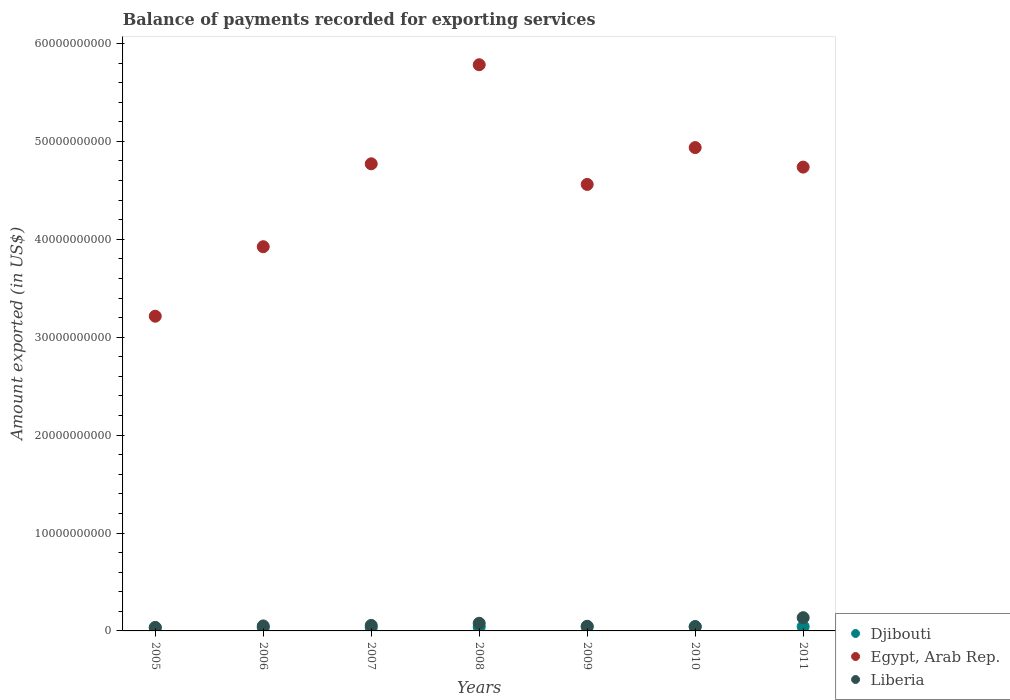How many different coloured dotlines are there?
Offer a very short reply. 3. Is the number of dotlines equal to the number of legend labels?
Provide a succinct answer. Yes. What is the amount exported in Liberia in 2008?
Your answer should be compact. 7.81e+08. Across all years, what is the maximum amount exported in Djibouti?
Provide a short and direct response. 4.40e+08. Across all years, what is the minimum amount exported in Liberia?
Offer a terse response. 3.55e+08. What is the total amount exported in Egypt, Arab Rep. in the graph?
Offer a very short reply. 3.19e+11. What is the difference between the amount exported in Liberia in 2006 and that in 2010?
Provide a succinct answer. 7.90e+07. What is the difference between the amount exported in Liberia in 2008 and the amount exported in Egypt, Arab Rep. in 2010?
Give a very brief answer. -4.86e+1. What is the average amount exported in Egypt, Arab Rep. per year?
Make the answer very short. 4.56e+1. In the year 2010, what is the difference between the amount exported in Liberia and amount exported in Djibouti?
Give a very brief answer. -8.59e+06. What is the ratio of the amount exported in Djibouti in 2005 to that in 2011?
Offer a terse response. 0.73. Is the amount exported in Liberia in 2008 less than that in 2009?
Ensure brevity in your answer.  No. What is the difference between the highest and the second highest amount exported in Egypt, Arab Rep.?
Make the answer very short. 8.46e+09. What is the difference between the highest and the lowest amount exported in Liberia?
Your answer should be very brief. 9.97e+08. Is the sum of the amount exported in Liberia in 2008 and 2009 greater than the maximum amount exported in Djibouti across all years?
Your response must be concise. Yes. Is the amount exported in Egypt, Arab Rep. strictly greater than the amount exported in Liberia over the years?
Make the answer very short. Yes. Is the amount exported in Djibouti strictly less than the amount exported in Egypt, Arab Rep. over the years?
Your response must be concise. Yes. How many dotlines are there?
Give a very brief answer. 3. How many years are there in the graph?
Offer a terse response. 7. What is the difference between two consecutive major ticks on the Y-axis?
Your answer should be very brief. 1.00e+1. Does the graph contain any zero values?
Your response must be concise. No. What is the title of the graph?
Provide a succinct answer. Balance of payments recorded for exporting services. Does "Ethiopia" appear as one of the legend labels in the graph?
Make the answer very short. No. What is the label or title of the Y-axis?
Your answer should be compact. Amount exported (in US$). What is the Amount exported (in US$) of Djibouti in 2005?
Your answer should be very brief. 3.20e+08. What is the Amount exported (in US$) in Egypt, Arab Rep. in 2005?
Ensure brevity in your answer.  3.21e+1. What is the Amount exported (in US$) in Liberia in 2005?
Make the answer very short. 3.55e+08. What is the Amount exported (in US$) of Djibouti in 2006?
Keep it short and to the point. 3.41e+08. What is the Amount exported (in US$) in Egypt, Arab Rep. in 2006?
Your answer should be compact. 3.92e+1. What is the Amount exported (in US$) of Liberia in 2006?
Your response must be concise. 5.09e+08. What is the Amount exported (in US$) in Djibouti in 2007?
Provide a succinct answer. 3.29e+08. What is the Amount exported (in US$) in Egypt, Arab Rep. in 2007?
Give a very brief answer. 4.77e+1. What is the Amount exported (in US$) of Liberia in 2007?
Ensure brevity in your answer.  5.62e+08. What is the Amount exported (in US$) of Djibouti in 2008?
Offer a terse response. 3.98e+08. What is the Amount exported (in US$) of Egypt, Arab Rep. in 2008?
Ensure brevity in your answer.  5.78e+1. What is the Amount exported (in US$) in Liberia in 2008?
Your answer should be very brief. 7.81e+08. What is the Amount exported (in US$) in Djibouti in 2009?
Provide a short and direct response. 4.23e+08. What is the Amount exported (in US$) in Egypt, Arab Rep. in 2009?
Make the answer very short. 4.56e+1. What is the Amount exported (in US$) in Liberia in 2009?
Your answer should be very brief. 4.72e+08. What is the Amount exported (in US$) of Djibouti in 2010?
Provide a succinct answer. 4.39e+08. What is the Amount exported (in US$) in Egypt, Arab Rep. in 2010?
Offer a terse response. 4.94e+1. What is the Amount exported (in US$) of Liberia in 2010?
Offer a very short reply. 4.30e+08. What is the Amount exported (in US$) in Djibouti in 2011?
Make the answer very short. 4.40e+08. What is the Amount exported (in US$) of Egypt, Arab Rep. in 2011?
Ensure brevity in your answer.  4.74e+1. What is the Amount exported (in US$) in Liberia in 2011?
Offer a very short reply. 1.35e+09. Across all years, what is the maximum Amount exported (in US$) of Djibouti?
Give a very brief answer. 4.40e+08. Across all years, what is the maximum Amount exported (in US$) of Egypt, Arab Rep.?
Give a very brief answer. 5.78e+1. Across all years, what is the maximum Amount exported (in US$) of Liberia?
Provide a short and direct response. 1.35e+09. Across all years, what is the minimum Amount exported (in US$) of Djibouti?
Your answer should be very brief. 3.20e+08. Across all years, what is the minimum Amount exported (in US$) of Egypt, Arab Rep.?
Offer a terse response. 3.21e+1. Across all years, what is the minimum Amount exported (in US$) of Liberia?
Provide a succinct answer. 3.55e+08. What is the total Amount exported (in US$) of Djibouti in the graph?
Your answer should be compact. 2.69e+09. What is the total Amount exported (in US$) in Egypt, Arab Rep. in the graph?
Your answer should be compact. 3.19e+11. What is the total Amount exported (in US$) of Liberia in the graph?
Provide a short and direct response. 4.46e+09. What is the difference between the Amount exported (in US$) of Djibouti in 2005 and that in 2006?
Offer a very short reply. -2.17e+07. What is the difference between the Amount exported (in US$) of Egypt, Arab Rep. in 2005 and that in 2006?
Your response must be concise. -7.10e+09. What is the difference between the Amount exported (in US$) in Liberia in 2005 and that in 2006?
Your answer should be very brief. -1.55e+08. What is the difference between the Amount exported (in US$) in Djibouti in 2005 and that in 2007?
Provide a succinct answer. -9.54e+06. What is the difference between the Amount exported (in US$) of Egypt, Arab Rep. in 2005 and that in 2007?
Make the answer very short. -1.56e+1. What is the difference between the Amount exported (in US$) of Liberia in 2005 and that in 2007?
Your response must be concise. -2.08e+08. What is the difference between the Amount exported (in US$) in Djibouti in 2005 and that in 2008?
Give a very brief answer. -7.85e+07. What is the difference between the Amount exported (in US$) in Egypt, Arab Rep. in 2005 and that in 2008?
Give a very brief answer. -2.57e+1. What is the difference between the Amount exported (in US$) of Liberia in 2005 and that in 2008?
Keep it short and to the point. -4.26e+08. What is the difference between the Amount exported (in US$) in Djibouti in 2005 and that in 2009?
Ensure brevity in your answer.  -1.03e+08. What is the difference between the Amount exported (in US$) in Egypt, Arab Rep. in 2005 and that in 2009?
Provide a succinct answer. -1.35e+1. What is the difference between the Amount exported (in US$) of Liberia in 2005 and that in 2009?
Give a very brief answer. -1.17e+08. What is the difference between the Amount exported (in US$) of Djibouti in 2005 and that in 2010?
Ensure brevity in your answer.  -1.19e+08. What is the difference between the Amount exported (in US$) of Egypt, Arab Rep. in 2005 and that in 2010?
Ensure brevity in your answer.  -1.72e+1. What is the difference between the Amount exported (in US$) in Liberia in 2005 and that in 2010?
Keep it short and to the point. -7.57e+07. What is the difference between the Amount exported (in US$) in Djibouti in 2005 and that in 2011?
Offer a very short reply. -1.20e+08. What is the difference between the Amount exported (in US$) in Egypt, Arab Rep. in 2005 and that in 2011?
Ensure brevity in your answer.  -1.52e+1. What is the difference between the Amount exported (in US$) of Liberia in 2005 and that in 2011?
Keep it short and to the point. -9.97e+08. What is the difference between the Amount exported (in US$) in Djibouti in 2006 and that in 2007?
Your response must be concise. 1.21e+07. What is the difference between the Amount exported (in US$) in Egypt, Arab Rep. in 2006 and that in 2007?
Give a very brief answer. -8.47e+09. What is the difference between the Amount exported (in US$) of Liberia in 2006 and that in 2007?
Provide a succinct answer. -5.28e+07. What is the difference between the Amount exported (in US$) in Djibouti in 2006 and that in 2008?
Offer a very short reply. -5.68e+07. What is the difference between the Amount exported (in US$) of Egypt, Arab Rep. in 2006 and that in 2008?
Make the answer very short. -1.86e+1. What is the difference between the Amount exported (in US$) in Liberia in 2006 and that in 2008?
Make the answer very short. -2.72e+08. What is the difference between the Amount exported (in US$) of Djibouti in 2006 and that in 2009?
Offer a very short reply. -8.13e+07. What is the difference between the Amount exported (in US$) of Egypt, Arab Rep. in 2006 and that in 2009?
Offer a terse response. -6.36e+09. What is the difference between the Amount exported (in US$) in Liberia in 2006 and that in 2009?
Provide a short and direct response. 3.73e+07. What is the difference between the Amount exported (in US$) of Djibouti in 2006 and that in 2010?
Make the answer very short. -9.75e+07. What is the difference between the Amount exported (in US$) in Egypt, Arab Rep. in 2006 and that in 2010?
Make the answer very short. -1.01e+1. What is the difference between the Amount exported (in US$) of Liberia in 2006 and that in 2010?
Keep it short and to the point. 7.90e+07. What is the difference between the Amount exported (in US$) of Djibouti in 2006 and that in 2011?
Give a very brief answer. -9.88e+07. What is the difference between the Amount exported (in US$) in Egypt, Arab Rep. in 2006 and that in 2011?
Make the answer very short. -8.13e+09. What is the difference between the Amount exported (in US$) of Liberia in 2006 and that in 2011?
Provide a succinct answer. -8.42e+08. What is the difference between the Amount exported (in US$) in Djibouti in 2007 and that in 2008?
Your answer should be very brief. -6.89e+07. What is the difference between the Amount exported (in US$) in Egypt, Arab Rep. in 2007 and that in 2008?
Keep it short and to the point. -1.01e+1. What is the difference between the Amount exported (in US$) of Liberia in 2007 and that in 2008?
Provide a succinct answer. -2.19e+08. What is the difference between the Amount exported (in US$) in Djibouti in 2007 and that in 2009?
Your response must be concise. -9.34e+07. What is the difference between the Amount exported (in US$) in Egypt, Arab Rep. in 2007 and that in 2009?
Ensure brevity in your answer.  2.11e+09. What is the difference between the Amount exported (in US$) in Liberia in 2007 and that in 2009?
Offer a terse response. 9.00e+07. What is the difference between the Amount exported (in US$) in Djibouti in 2007 and that in 2010?
Offer a very short reply. -1.10e+08. What is the difference between the Amount exported (in US$) in Egypt, Arab Rep. in 2007 and that in 2010?
Your answer should be compact. -1.66e+09. What is the difference between the Amount exported (in US$) of Liberia in 2007 and that in 2010?
Offer a very short reply. 1.32e+08. What is the difference between the Amount exported (in US$) in Djibouti in 2007 and that in 2011?
Give a very brief answer. -1.11e+08. What is the difference between the Amount exported (in US$) of Egypt, Arab Rep. in 2007 and that in 2011?
Your answer should be compact. 3.36e+08. What is the difference between the Amount exported (in US$) in Liberia in 2007 and that in 2011?
Your response must be concise. -7.90e+08. What is the difference between the Amount exported (in US$) in Djibouti in 2008 and that in 2009?
Your answer should be very brief. -2.45e+07. What is the difference between the Amount exported (in US$) of Egypt, Arab Rep. in 2008 and that in 2009?
Give a very brief answer. 1.22e+1. What is the difference between the Amount exported (in US$) of Liberia in 2008 and that in 2009?
Provide a short and direct response. 3.09e+08. What is the difference between the Amount exported (in US$) in Djibouti in 2008 and that in 2010?
Make the answer very short. -4.07e+07. What is the difference between the Amount exported (in US$) in Egypt, Arab Rep. in 2008 and that in 2010?
Ensure brevity in your answer.  8.46e+09. What is the difference between the Amount exported (in US$) of Liberia in 2008 and that in 2010?
Ensure brevity in your answer.  3.51e+08. What is the difference between the Amount exported (in US$) in Djibouti in 2008 and that in 2011?
Keep it short and to the point. -4.20e+07. What is the difference between the Amount exported (in US$) of Egypt, Arab Rep. in 2008 and that in 2011?
Provide a succinct answer. 1.05e+1. What is the difference between the Amount exported (in US$) of Liberia in 2008 and that in 2011?
Your response must be concise. -5.71e+08. What is the difference between the Amount exported (in US$) of Djibouti in 2009 and that in 2010?
Give a very brief answer. -1.63e+07. What is the difference between the Amount exported (in US$) in Egypt, Arab Rep. in 2009 and that in 2010?
Offer a terse response. -3.76e+09. What is the difference between the Amount exported (in US$) of Liberia in 2009 and that in 2010?
Your response must be concise. 4.17e+07. What is the difference between the Amount exported (in US$) of Djibouti in 2009 and that in 2011?
Make the answer very short. -1.76e+07. What is the difference between the Amount exported (in US$) in Egypt, Arab Rep. in 2009 and that in 2011?
Offer a very short reply. -1.77e+09. What is the difference between the Amount exported (in US$) of Liberia in 2009 and that in 2011?
Make the answer very short. -8.80e+08. What is the difference between the Amount exported (in US$) in Djibouti in 2010 and that in 2011?
Offer a terse response. -1.29e+06. What is the difference between the Amount exported (in US$) of Egypt, Arab Rep. in 2010 and that in 2011?
Give a very brief answer. 1.99e+09. What is the difference between the Amount exported (in US$) of Liberia in 2010 and that in 2011?
Your answer should be compact. -9.21e+08. What is the difference between the Amount exported (in US$) of Djibouti in 2005 and the Amount exported (in US$) of Egypt, Arab Rep. in 2006?
Give a very brief answer. -3.89e+1. What is the difference between the Amount exported (in US$) in Djibouti in 2005 and the Amount exported (in US$) in Liberia in 2006?
Your answer should be compact. -1.90e+08. What is the difference between the Amount exported (in US$) of Egypt, Arab Rep. in 2005 and the Amount exported (in US$) of Liberia in 2006?
Give a very brief answer. 3.16e+1. What is the difference between the Amount exported (in US$) in Djibouti in 2005 and the Amount exported (in US$) in Egypt, Arab Rep. in 2007?
Your response must be concise. -4.74e+1. What is the difference between the Amount exported (in US$) in Djibouti in 2005 and the Amount exported (in US$) in Liberia in 2007?
Make the answer very short. -2.42e+08. What is the difference between the Amount exported (in US$) of Egypt, Arab Rep. in 2005 and the Amount exported (in US$) of Liberia in 2007?
Give a very brief answer. 3.16e+1. What is the difference between the Amount exported (in US$) in Djibouti in 2005 and the Amount exported (in US$) in Egypt, Arab Rep. in 2008?
Your response must be concise. -5.75e+1. What is the difference between the Amount exported (in US$) in Djibouti in 2005 and the Amount exported (in US$) in Liberia in 2008?
Give a very brief answer. -4.61e+08. What is the difference between the Amount exported (in US$) of Egypt, Arab Rep. in 2005 and the Amount exported (in US$) of Liberia in 2008?
Your answer should be compact. 3.14e+1. What is the difference between the Amount exported (in US$) in Djibouti in 2005 and the Amount exported (in US$) in Egypt, Arab Rep. in 2009?
Provide a succinct answer. -4.53e+1. What is the difference between the Amount exported (in US$) in Djibouti in 2005 and the Amount exported (in US$) in Liberia in 2009?
Give a very brief answer. -1.52e+08. What is the difference between the Amount exported (in US$) of Egypt, Arab Rep. in 2005 and the Amount exported (in US$) of Liberia in 2009?
Keep it short and to the point. 3.17e+1. What is the difference between the Amount exported (in US$) of Djibouti in 2005 and the Amount exported (in US$) of Egypt, Arab Rep. in 2010?
Give a very brief answer. -4.90e+1. What is the difference between the Amount exported (in US$) of Djibouti in 2005 and the Amount exported (in US$) of Liberia in 2010?
Your answer should be compact. -1.11e+08. What is the difference between the Amount exported (in US$) in Egypt, Arab Rep. in 2005 and the Amount exported (in US$) in Liberia in 2010?
Provide a short and direct response. 3.17e+1. What is the difference between the Amount exported (in US$) in Djibouti in 2005 and the Amount exported (in US$) in Egypt, Arab Rep. in 2011?
Provide a succinct answer. -4.71e+1. What is the difference between the Amount exported (in US$) in Djibouti in 2005 and the Amount exported (in US$) in Liberia in 2011?
Keep it short and to the point. -1.03e+09. What is the difference between the Amount exported (in US$) of Egypt, Arab Rep. in 2005 and the Amount exported (in US$) of Liberia in 2011?
Ensure brevity in your answer.  3.08e+1. What is the difference between the Amount exported (in US$) in Djibouti in 2006 and the Amount exported (in US$) in Egypt, Arab Rep. in 2007?
Your answer should be compact. -4.74e+1. What is the difference between the Amount exported (in US$) of Djibouti in 2006 and the Amount exported (in US$) of Liberia in 2007?
Give a very brief answer. -2.21e+08. What is the difference between the Amount exported (in US$) in Egypt, Arab Rep. in 2006 and the Amount exported (in US$) in Liberia in 2007?
Provide a succinct answer. 3.87e+1. What is the difference between the Amount exported (in US$) in Djibouti in 2006 and the Amount exported (in US$) in Egypt, Arab Rep. in 2008?
Offer a terse response. -5.75e+1. What is the difference between the Amount exported (in US$) of Djibouti in 2006 and the Amount exported (in US$) of Liberia in 2008?
Make the answer very short. -4.40e+08. What is the difference between the Amount exported (in US$) in Egypt, Arab Rep. in 2006 and the Amount exported (in US$) in Liberia in 2008?
Give a very brief answer. 3.85e+1. What is the difference between the Amount exported (in US$) of Djibouti in 2006 and the Amount exported (in US$) of Egypt, Arab Rep. in 2009?
Keep it short and to the point. -4.53e+1. What is the difference between the Amount exported (in US$) in Djibouti in 2006 and the Amount exported (in US$) in Liberia in 2009?
Ensure brevity in your answer.  -1.31e+08. What is the difference between the Amount exported (in US$) of Egypt, Arab Rep. in 2006 and the Amount exported (in US$) of Liberia in 2009?
Your answer should be compact. 3.88e+1. What is the difference between the Amount exported (in US$) of Djibouti in 2006 and the Amount exported (in US$) of Egypt, Arab Rep. in 2010?
Your response must be concise. -4.90e+1. What is the difference between the Amount exported (in US$) of Djibouti in 2006 and the Amount exported (in US$) of Liberia in 2010?
Give a very brief answer. -8.89e+07. What is the difference between the Amount exported (in US$) in Egypt, Arab Rep. in 2006 and the Amount exported (in US$) in Liberia in 2010?
Ensure brevity in your answer.  3.88e+1. What is the difference between the Amount exported (in US$) of Djibouti in 2006 and the Amount exported (in US$) of Egypt, Arab Rep. in 2011?
Provide a short and direct response. -4.70e+1. What is the difference between the Amount exported (in US$) of Djibouti in 2006 and the Amount exported (in US$) of Liberia in 2011?
Keep it short and to the point. -1.01e+09. What is the difference between the Amount exported (in US$) of Egypt, Arab Rep. in 2006 and the Amount exported (in US$) of Liberia in 2011?
Offer a very short reply. 3.79e+1. What is the difference between the Amount exported (in US$) in Djibouti in 2007 and the Amount exported (in US$) in Egypt, Arab Rep. in 2008?
Provide a succinct answer. -5.75e+1. What is the difference between the Amount exported (in US$) of Djibouti in 2007 and the Amount exported (in US$) of Liberia in 2008?
Offer a very short reply. -4.52e+08. What is the difference between the Amount exported (in US$) in Egypt, Arab Rep. in 2007 and the Amount exported (in US$) in Liberia in 2008?
Your answer should be very brief. 4.69e+1. What is the difference between the Amount exported (in US$) in Djibouti in 2007 and the Amount exported (in US$) in Egypt, Arab Rep. in 2009?
Make the answer very short. -4.53e+1. What is the difference between the Amount exported (in US$) of Djibouti in 2007 and the Amount exported (in US$) of Liberia in 2009?
Provide a short and direct response. -1.43e+08. What is the difference between the Amount exported (in US$) of Egypt, Arab Rep. in 2007 and the Amount exported (in US$) of Liberia in 2009?
Provide a short and direct response. 4.72e+1. What is the difference between the Amount exported (in US$) of Djibouti in 2007 and the Amount exported (in US$) of Egypt, Arab Rep. in 2010?
Ensure brevity in your answer.  -4.90e+1. What is the difference between the Amount exported (in US$) in Djibouti in 2007 and the Amount exported (in US$) in Liberia in 2010?
Your answer should be very brief. -1.01e+08. What is the difference between the Amount exported (in US$) of Egypt, Arab Rep. in 2007 and the Amount exported (in US$) of Liberia in 2010?
Your response must be concise. 4.73e+1. What is the difference between the Amount exported (in US$) of Djibouti in 2007 and the Amount exported (in US$) of Egypt, Arab Rep. in 2011?
Give a very brief answer. -4.70e+1. What is the difference between the Amount exported (in US$) in Djibouti in 2007 and the Amount exported (in US$) in Liberia in 2011?
Your response must be concise. -1.02e+09. What is the difference between the Amount exported (in US$) of Egypt, Arab Rep. in 2007 and the Amount exported (in US$) of Liberia in 2011?
Your answer should be compact. 4.64e+1. What is the difference between the Amount exported (in US$) of Djibouti in 2008 and the Amount exported (in US$) of Egypt, Arab Rep. in 2009?
Provide a short and direct response. -4.52e+1. What is the difference between the Amount exported (in US$) in Djibouti in 2008 and the Amount exported (in US$) in Liberia in 2009?
Provide a succinct answer. -7.39e+07. What is the difference between the Amount exported (in US$) in Egypt, Arab Rep. in 2008 and the Amount exported (in US$) in Liberia in 2009?
Provide a succinct answer. 5.74e+1. What is the difference between the Amount exported (in US$) in Djibouti in 2008 and the Amount exported (in US$) in Egypt, Arab Rep. in 2010?
Offer a terse response. -4.90e+1. What is the difference between the Amount exported (in US$) in Djibouti in 2008 and the Amount exported (in US$) in Liberia in 2010?
Offer a very short reply. -3.21e+07. What is the difference between the Amount exported (in US$) of Egypt, Arab Rep. in 2008 and the Amount exported (in US$) of Liberia in 2010?
Offer a very short reply. 5.74e+1. What is the difference between the Amount exported (in US$) of Djibouti in 2008 and the Amount exported (in US$) of Egypt, Arab Rep. in 2011?
Your response must be concise. -4.70e+1. What is the difference between the Amount exported (in US$) in Djibouti in 2008 and the Amount exported (in US$) in Liberia in 2011?
Keep it short and to the point. -9.54e+08. What is the difference between the Amount exported (in US$) of Egypt, Arab Rep. in 2008 and the Amount exported (in US$) of Liberia in 2011?
Ensure brevity in your answer.  5.65e+1. What is the difference between the Amount exported (in US$) in Djibouti in 2009 and the Amount exported (in US$) in Egypt, Arab Rep. in 2010?
Your response must be concise. -4.89e+1. What is the difference between the Amount exported (in US$) in Djibouti in 2009 and the Amount exported (in US$) in Liberia in 2010?
Give a very brief answer. -7.69e+06. What is the difference between the Amount exported (in US$) in Egypt, Arab Rep. in 2009 and the Amount exported (in US$) in Liberia in 2010?
Your answer should be very brief. 4.52e+1. What is the difference between the Amount exported (in US$) of Djibouti in 2009 and the Amount exported (in US$) of Egypt, Arab Rep. in 2011?
Your answer should be compact. -4.69e+1. What is the difference between the Amount exported (in US$) of Djibouti in 2009 and the Amount exported (in US$) of Liberia in 2011?
Provide a succinct answer. -9.29e+08. What is the difference between the Amount exported (in US$) of Egypt, Arab Rep. in 2009 and the Amount exported (in US$) of Liberia in 2011?
Your response must be concise. 4.42e+1. What is the difference between the Amount exported (in US$) in Djibouti in 2010 and the Amount exported (in US$) in Egypt, Arab Rep. in 2011?
Make the answer very short. -4.69e+1. What is the difference between the Amount exported (in US$) of Djibouti in 2010 and the Amount exported (in US$) of Liberia in 2011?
Ensure brevity in your answer.  -9.13e+08. What is the difference between the Amount exported (in US$) of Egypt, Arab Rep. in 2010 and the Amount exported (in US$) of Liberia in 2011?
Your response must be concise. 4.80e+1. What is the average Amount exported (in US$) of Djibouti per year?
Make the answer very short. 3.84e+08. What is the average Amount exported (in US$) in Egypt, Arab Rep. per year?
Your answer should be compact. 4.56e+1. What is the average Amount exported (in US$) in Liberia per year?
Provide a succinct answer. 6.37e+08. In the year 2005, what is the difference between the Amount exported (in US$) of Djibouti and Amount exported (in US$) of Egypt, Arab Rep.?
Provide a succinct answer. -3.18e+1. In the year 2005, what is the difference between the Amount exported (in US$) in Djibouti and Amount exported (in US$) in Liberia?
Offer a very short reply. -3.49e+07. In the year 2005, what is the difference between the Amount exported (in US$) in Egypt, Arab Rep. and Amount exported (in US$) in Liberia?
Keep it short and to the point. 3.18e+1. In the year 2006, what is the difference between the Amount exported (in US$) of Djibouti and Amount exported (in US$) of Egypt, Arab Rep.?
Make the answer very short. -3.89e+1. In the year 2006, what is the difference between the Amount exported (in US$) in Djibouti and Amount exported (in US$) in Liberia?
Your answer should be compact. -1.68e+08. In the year 2006, what is the difference between the Amount exported (in US$) in Egypt, Arab Rep. and Amount exported (in US$) in Liberia?
Your answer should be very brief. 3.87e+1. In the year 2007, what is the difference between the Amount exported (in US$) of Djibouti and Amount exported (in US$) of Egypt, Arab Rep.?
Provide a short and direct response. -4.74e+1. In the year 2007, what is the difference between the Amount exported (in US$) in Djibouti and Amount exported (in US$) in Liberia?
Offer a terse response. -2.33e+08. In the year 2007, what is the difference between the Amount exported (in US$) of Egypt, Arab Rep. and Amount exported (in US$) of Liberia?
Your answer should be very brief. 4.71e+1. In the year 2008, what is the difference between the Amount exported (in US$) of Djibouti and Amount exported (in US$) of Egypt, Arab Rep.?
Give a very brief answer. -5.74e+1. In the year 2008, what is the difference between the Amount exported (in US$) in Djibouti and Amount exported (in US$) in Liberia?
Offer a terse response. -3.83e+08. In the year 2008, what is the difference between the Amount exported (in US$) in Egypt, Arab Rep. and Amount exported (in US$) in Liberia?
Provide a succinct answer. 5.70e+1. In the year 2009, what is the difference between the Amount exported (in US$) of Djibouti and Amount exported (in US$) of Egypt, Arab Rep.?
Your response must be concise. -4.52e+1. In the year 2009, what is the difference between the Amount exported (in US$) of Djibouti and Amount exported (in US$) of Liberia?
Ensure brevity in your answer.  -4.94e+07. In the year 2009, what is the difference between the Amount exported (in US$) of Egypt, Arab Rep. and Amount exported (in US$) of Liberia?
Offer a very short reply. 4.51e+1. In the year 2010, what is the difference between the Amount exported (in US$) in Djibouti and Amount exported (in US$) in Egypt, Arab Rep.?
Keep it short and to the point. -4.89e+1. In the year 2010, what is the difference between the Amount exported (in US$) in Djibouti and Amount exported (in US$) in Liberia?
Offer a terse response. 8.59e+06. In the year 2010, what is the difference between the Amount exported (in US$) in Egypt, Arab Rep. and Amount exported (in US$) in Liberia?
Offer a very short reply. 4.89e+1. In the year 2011, what is the difference between the Amount exported (in US$) of Djibouti and Amount exported (in US$) of Egypt, Arab Rep.?
Make the answer very short. -4.69e+1. In the year 2011, what is the difference between the Amount exported (in US$) of Djibouti and Amount exported (in US$) of Liberia?
Your response must be concise. -9.11e+08. In the year 2011, what is the difference between the Amount exported (in US$) of Egypt, Arab Rep. and Amount exported (in US$) of Liberia?
Your answer should be very brief. 4.60e+1. What is the ratio of the Amount exported (in US$) of Djibouti in 2005 to that in 2006?
Provide a short and direct response. 0.94. What is the ratio of the Amount exported (in US$) in Egypt, Arab Rep. in 2005 to that in 2006?
Provide a succinct answer. 0.82. What is the ratio of the Amount exported (in US$) in Liberia in 2005 to that in 2006?
Give a very brief answer. 0.7. What is the ratio of the Amount exported (in US$) of Djibouti in 2005 to that in 2007?
Provide a short and direct response. 0.97. What is the ratio of the Amount exported (in US$) of Egypt, Arab Rep. in 2005 to that in 2007?
Your answer should be compact. 0.67. What is the ratio of the Amount exported (in US$) of Liberia in 2005 to that in 2007?
Your answer should be compact. 0.63. What is the ratio of the Amount exported (in US$) in Djibouti in 2005 to that in 2008?
Provide a succinct answer. 0.8. What is the ratio of the Amount exported (in US$) of Egypt, Arab Rep. in 2005 to that in 2008?
Your response must be concise. 0.56. What is the ratio of the Amount exported (in US$) of Liberia in 2005 to that in 2008?
Your answer should be very brief. 0.45. What is the ratio of the Amount exported (in US$) of Djibouti in 2005 to that in 2009?
Ensure brevity in your answer.  0.76. What is the ratio of the Amount exported (in US$) of Egypt, Arab Rep. in 2005 to that in 2009?
Offer a very short reply. 0.7. What is the ratio of the Amount exported (in US$) in Liberia in 2005 to that in 2009?
Your answer should be very brief. 0.75. What is the ratio of the Amount exported (in US$) in Djibouti in 2005 to that in 2010?
Provide a succinct answer. 0.73. What is the ratio of the Amount exported (in US$) of Egypt, Arab Rep. in 2005 to that in 2010?
Your response must be concise. 0.65. What is the ratio of the Amount exported (in US$) of Liberia in 2005 to that in 2010?
Offer a very short reply. 0.82. What is the ratio of the Amount exported (in US$) of Djibouti in 2005 to that in 2011?
Ensure brevity in your answer.  0.73. What is the ratio of the Amount exported (in US$) in Egypt, Arab Rep. in 2005 to that in 2011?
Keep it short and to the point. 0.68. What is the ratio of the Amount exported (in US$) in Liberia in 2005 to that in 2011?
Your answer should be very brief. 0.26. What is the ratio of the Amount exported (in US$) in Djibouti in 2006 to that in 2007?
Offer a terse response. 1.04. What is the ratio of the Amount exported (in US$) of Egypt, Arab Rep. in 2006 to that in 2007?
Make the answer very short. 0.82. What is the ratio of the Amount exported (in US$) in Liberia in 2006 to that in 2007?
Give a very brief answer. 0.91. What is the ratio of the Amount exported (in US$) in Djibouti in 2006 to that in 2008?
Provide a short and direct response. 0.86. What is the ratio of the Amount exported (in US$) in Egypt, Arab Rep. in 2006 to that in 2008?
Offer a very short reply. 0.68. What is the ratio of the Amount exported (in US$) of Liberia in 2006 to that in 2008?
Ensure brevity in your answer.  0.65. What is the ratio of the Amount exported (in US$) of Djibouti in 2006 to that in 2009?
Ensure brevity in your answer.  0.81. What is the ratio of the Amount exported (in US$) in Egypt, Arab Rep. in 2006 to that in 2009?
Provide a succinct answer. 0.86. What is the ratio of the Amount exported (in US$) in Liberia in 2006 to that in 2009?
Your answer should be compact. 1.08. What is the ratio of the Amount exported (in US$) in Egypt, Arab Rep. in 2006 to that in 2010?
Provide a succinct answer. 0.79. What is the ratio of the Amount exported (in US$) of Liberia in 2006 to that in 2010?
Provide a short and direct response. 1.18. What is the ratio of the Amount exported (in US$) of Djibouti in 2006 to that in 2011?
Ensure brevity in your answer.  0.78. What is the ratio of the Amount exported (in US$) of Egypt, Arab Rep. in 2006 to that in 2011?
Give a very brief answer. 0.83. What is the ratio of the Amount exported (in US$) in Liberia in 2006 to that in 2011?
Your answer should be very brief. 0.38. What is the ratio of the Amount exported (in US$) of Djibouti in 2007 to that in 2008?
Your response must be concise. 0.83. What is the ratio of the Amount exported (in US$) of Egypt, Arab Rep. in 2007 to that in 2008?
Make the answer very short. 0.82. What is the ratio of the Amount exported (in US$) of Liberia in 2007 to that in 2008?
Provide a short and direct response. 0.72. What is the ratio of the Amount exported (in US$) of Djibouti in 2007 to that in 2009?
Give a very brief answer. 0.78. What is the ratio of the Amount exported (in US$) of Egypt, Arab Rep. in 2007 to that in 2009?
Offer a terse response. 1.05. What is the ratio of the Amount exported (in US$) of Liberia in 2007 to that in 2009?
Your answer should be compact. 1.19. What is the ratio of the Amount exported (in US$) of Djibouti in 2007 to that in 2010?
Provide a short and direct response. 0.75. What is the ratio of the Amount exported (in US$) of Egypt, Arab Rep. in 2007 to that in 2010?
Offer a very short reply. 0.97. What is the ratio of the Amount exported (in US$) of Liberia in 2007 to that in 2010?
Make the answer very short. 1.31. What is the ratio of the Amount exported (in US$) in Djibouti in 2007 to that in 2011?
Your response must be concise. 0.75. What is the ratio of the Amount exported (in US$) in Egypt, Arab Rep. in 2007 to that in 2011?
Ensure brevity in your answer.  1.01. What is the ratio of the Amount exported (in US$) in Liberia in 2007 to that in 2011?
Provide a short and direct response. 0.42. What is the ratio of the Amount exported (in US$) of Djibouti in 2008 to that in 2009?
Provide a succinct answer. 0.94. What is the ratio of the Amount exported (in US$) of Egypt, Arab Rep. in 2008 to that in 2009?
Make the answer very short. 1.27. What is the ratio of the Amount exported (in US$) in Liberia in 2008 to that in 2009?
Offer a very short reply. 1.65. What is the ratio of the Amount exported (in US$) of Djibouti in 2008 to that in 2010?
Make the answer very short. 0.91. What is the ratio of the Amount exported (in US$) of Egypt, Arab Rep. in 2008 to that in 2010?
Make the answer very short. 1.17. What is the ratio of the Amount exported (in US$) of Liberia in 2008 to that in 2010?
Provide a succinct answer. 1.81. What is the ratio of the Amount exported (in US$) of Djibouti in 2008 to that in 2011?
Give a very brief answer. 0.9. What is the ratio of the Amount exported (in US$) of Egypt, Arab Rep. in 2008 to that in 2011?
Make the answer very short. 1.22. What is the ratio of the Amount exported (in US$) of Liberia in 2008 to that in 2011?
Keep it short and to the point. 0.58. What is the ratio of the Amount exported (in US$) in Djibouti in 2009 to that in 2010?
Provide a short and direct response. 0.96. What is the ratio of the Amount exported (in US$) of Egypt, Arab Rep. in 2009 to that in 2010?
Provide a short and direct response. 0.92. What is the ratio of the Amount exported (in US$) in Liberia in 2009 to that in 2010?
Your response must be concise. 1.1. What is the ratio of the Amount exported (in US$) in Djibouti in 2009 to that in 2011?
Ensure brevity in your answer.  0.96. What is the ratio of the Amount exported (in US$) of Egypt, Arab Rep. in 2009 to that in 2011?
Make the answer very short. 0.96. What is the ratio of the Amount exported (in US$) of Liberia in 2009 to that in 2011?
Keep it short and to the point. 0.35. What is the ratio of the Amount exported (in US$) of Egypt, Arab Rep. in 2010 to that in 2011?
Offer a very short reply. 1.04. What is the ratio of the Amount exported (in US$) of Liberia in 2010 to that in 2011?
Provide a short and direct response. 0.32. What is the difference between the highest and the second highest Amount exported (in US$) of Djibouti?
Offer a very short reply. 1.29e+06. What is the difference between the highest and the second highest Amount exported (in US$) of Egypt, Arab Rep.?
Offer a terse response. 8.46e+09. What is the difference between the highest and the second highest Amount exported (in US$) in Liberia?
Provide a short and direct response. 5.71e+08. What is the difference between the highest and the lowest Amount exported (in US$) of Djibouti?
Offer a very short reply. 1.20e+08. What is the difference between the highest and the lowest Amount exported (in US$) of Egypt, Arab Rep.?
Provide a succinct answer. 2.57e+1. What is the difference between the highest and the lowest Amount exported (in US$) of Liberia?
Offer a terse response. 9.97e+08. 